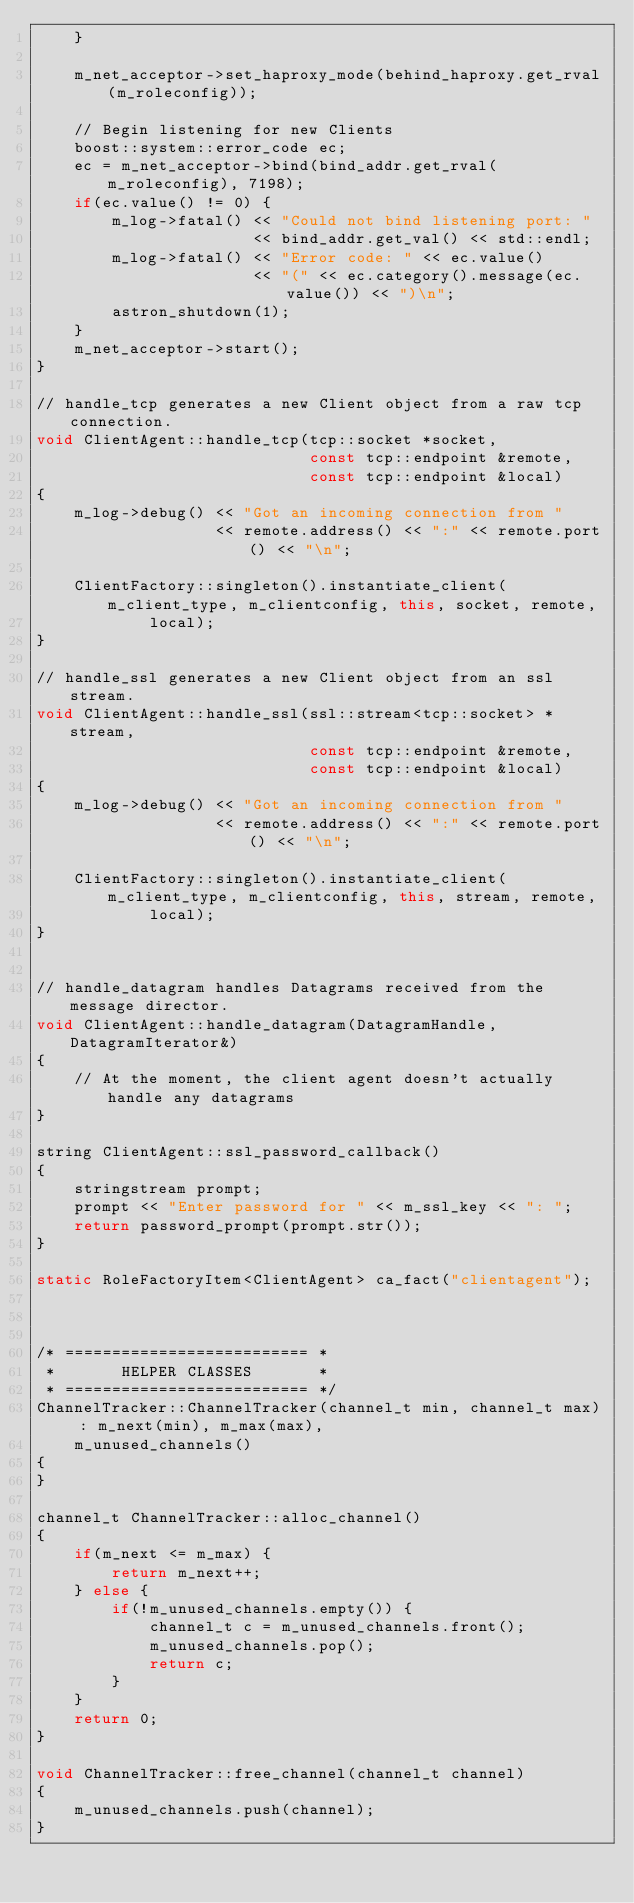Convert code to text. <code><loc_0><loc_0><loc_500><loc_500><_C++_>    }

    m_net_acceptor->set_haproxy_mode(behind_haproxy.get_rval(m_roleconfig));

    // Begin listening for new Clients
    boost::system::error_code ec;
    ec = m_net_acceptor->bind(bind_addr.get_rval(m_roleconfig), 7198);
    if(ec.value() != 0) {
        m_log->fatal() << "Could not bind listening port: "
                       << bind_addr.get_val() << std::endl;
        m_log->fatal() << "Error code: " << ec.value()
                       << "(" << ec.category().message(ec.value()) << ")\n";
        astron_shutdown(1);
    }
    m_net_acceptor->start();
}

// handle_tcp generates a new Client object from a raw tcp connection.
void ClientAgent::handle_tcp(tcp::socket *socket,
                             const tcp::endpoint &remote,
                             const tcp::endpoint &local)
{
    m_log->debug() << "Got an incoming connection from "
                   << remote.address() << ":" << remote.port() << "\n";

    ClientFactory::singleton().instantiate_client(m_client_type, m_clientconfig, this, socket, remote,
            local);
}

// handle_ssl generates a new Client object from an ssl stream.
void ClientAgent::handle_ssl(ssl::stream<tcp::socket> *stream,
                             const tcp::endpoint &remote,
                             const tcp::endpoint &local)
{
    m_log->debug() << "Got an incoming connection from "
                   << remote.address() << ":" << remote.port() << "\n";

    ClientFactory::singleton().instantiate_client(m_client_type, m_clientconfig, this, stream, remote,
            local);
}


// handle_datagram handles Datagrams received from the message director.
void ClientAgent::handle_datagram(DatagramHandle, DatagramIterator&)
{
    // At the moment, the client agent doesn't actually handle any datagrams
}

string ClientAgent::ssl_password_callback()
{
    stringstream prompt;
    prompt << "Enter password for " << m_ssl_key << ": ";
    return password_prompt(prompt.str());
}

static RoleFactoryItem<ClientAgent> ca_fact("clientagent");



/* ========================== *
 *       HELPER CLASSES       *
 * ========================== */
ChannelTracker::ChannelTracker(channel_t min, channel_t max) : m_next(min), m_max(max),
    m_unused_channels()
{
}

channel_t ChannelTracker::alloc_channel()
{
    if(m_next <= m_max) {
        return m_next++;
    } else {
        if(!m_unused_channels.empty()) {
            channel_t c = m_unused_channels.front();
            m_unused_channels.pop();
            return c;
        }
    }
    return 0;
}

void ChannelTracker::free_channel(channel_t channel)
{
    m_unused_channels.push(channel);
}
</code> 